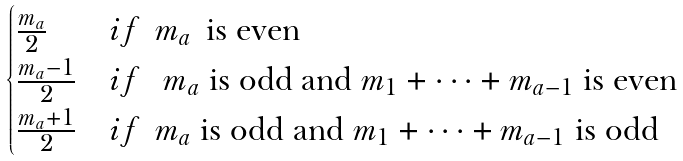Convert formula to latex. <formula><loc_0><loc_0><loc_500><loc_500>\begin{cases} \frac { m _ { a } } { 2 } & i f \, \ m _ { a } \, \ \text {is even} \\ \frac { m _ { a } - 1 } { 2 } & i f \, \ \text { $m_{a}$ is odd and $m_{1} + \cdots + m_{a-1}$ is even} \\ \frac { m _ { a } + 1 } { 2 } & i f \, \ \text {$m_{a}$ is odd and $m_{1} + \cdots + m_{a-1}$ is odd} \end{cases}</formula> 